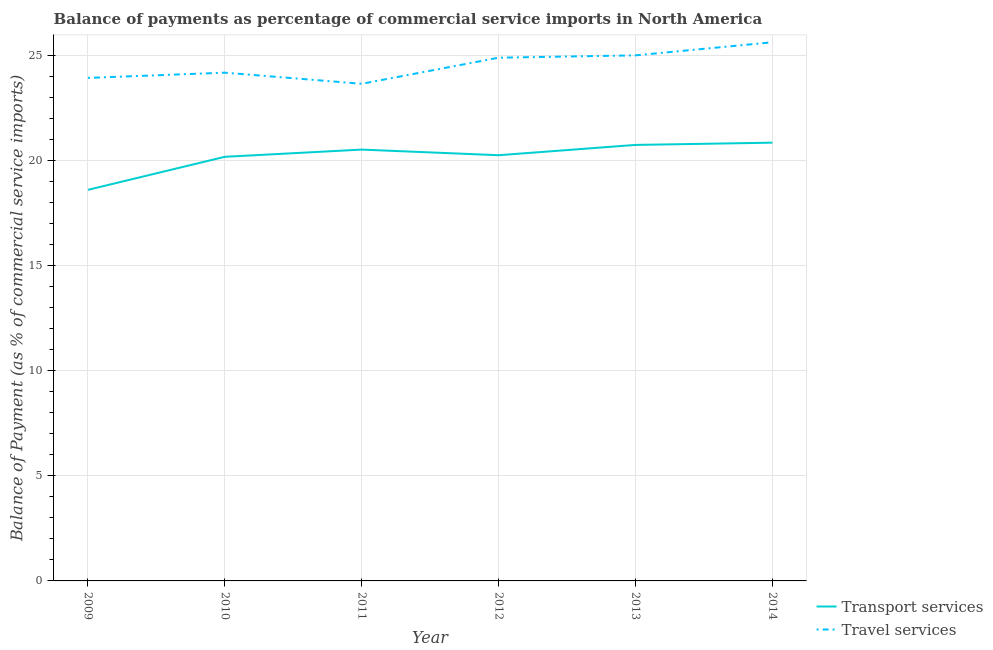Does the line corresponding to balance of payments of transport services intersect with the line corresponding to balance of payments of travel services?
Offer a very short reply. No. What is the balance of payments of travel services in 2013?
Make the answer very short. 24.99. Across all years, what is the maximum balance of payments of travel services?
Offer a very short reply. 25.61. Across all years, what is the minimum balance of payments of transport services?
Your answer should be compact. 18.59. In which year was the balance of payments of transport services minimum?
Give a very brief answer. 2009. What is the total balance of payments of travel services in the graph?
Your answer should be very brief. 147.2. What is the difference between the balance of payments of travel services in 2013 and that in 2014?
Your response must be concise. -0.62. What is the difference between the balance of payments of transport services in 2010 and the balance of payments of travel services in 2009?
Your response must be concise. -3.75. What is the average balance of payments of transport services per year?
Provide a short and direct response. 20.18. In the year 2014, what is the difference between the balance of payments of travel services and balance of payments of transport services?
Offer a very short reply. 4.77. What is the ratio of the balance of payments of travel services in 2011 to that in 2014?
Keep it short and to the point. 0.92. What is the difference between the highest and the second highest balance of payments of travel services?
Offer a very short reply. 0.62. What is the difference between the highest and the lowest balance of payments of transport services?
Offer a terse response. 2.24. In how many years, is the balance of payments of transport services greater than the average balance of payments of transport services taken over all years?
Keep it short and to the point. 4. Is the sum of the balance of payments of travel services in 2012 and 2014 greater than the maximum balance of payments of transport services across all years?
Offer a terse response. Yes. Does the balance of payments of travel services monotonically increase over the years?
Offer a terse response. No. Is the balance of payments of travel services strictly less than the balance of payments of transport services over the years?
Your answer should be very brief. No. Are the values on the major ticks of Y-axis written in scientific E-notation?
Keep it short and to the point. No. Does the graph contain any zero values?
Give a very brief answer. No. Does the graph contain grids?
Keep it short and to the point. Yes. Where does the legend appear in the graph?
Give a very brief answer. Bottom right. How many legend labels are there?
Offer a very short reply. 2. How are the legend labels stacked?
Make the answer very short. Vertical. What is the title of the graph?
Your answer should be compact. Balance of payments as percentage of commercial service imports in North America. What is the label or title of the X-axis?
Ensure brevity in your answer.  Year. What is the label or title of the Y-axis?
Your answer should be very brief. Balance of Payment (as % of commercial service imports). What is the Balance of Payment (as % of commercial service imports) in Transport services in 2009?
Provide a short and direct response. 18.59. What is the Balance of Payment (as % of commercial service imports) of Travel services in 2009?
Offer a terse response. 23.92. What is the Balance of Payment (as % of commercial service imports) of Transport services in 2010?
Ensure brevity in your answer.  20.17. What is the Balance of Payment (as % of commercial service imports) in Travel services in 2010?
Provide a succinct answer. 24.17. What is the Balance of Payment (as % of commercial service imports) of Transport services in 2011?
Offer a terse response. 20.51. What is the Balance of Payment (as % of commercial service imports) in Travel services in 2011?
Offer a terse response. 23.64. What is the Balance of Payment (as % of commercial service imports) of Transport services in 2012?
Your response must be concise. 20.24. What is the Balance of Payment (as % of commercial service imports) in Travel services in 2012?
Your answer should be compact. 24.88. What is the Balance of Payment (as % of commercial service imports) in Transport services in 2013?
Your answer should be very brief. 20.73. What is the Balance of Payment (as % of commercial service imports) in Travel services in 2013?
Your response must be concise. 24.99. What is the Balance of Payment (as % of commercial service imports) in Transport services in 2014?
Your answer should be compact. 20.84. What is the Balance of Payment (as % of commercial service imports) of Travel services in 2014?
Your answer should be compact. 25.61. Across all years, what is the maximum Balance of Payment (as % of commercial service imports) in Transport services?
Your answer should be very brief. 20.84. Across all years, what is the maximum Balance of Payment (as % of commercial service imports) of Travel services?
Your answer should be very brief. 25.61. Across all years, what is the minimum Balance of Payment (as % of commercial service imports) of Transport services?
Keep it short and to the point. 18.59. Across all years, what is the minimum Balance of Payment (as % of commercial service imports) in Travel services?
Your answer should be compact. 23.64. What is the total Balance of Payment (as % of commercial service imports) in Transport services in the graph?
Keep it short and to the point. 121.08. What is the total Balance of Payment (as % of commercial service imports) in Travel services in the graph?
Provide a short and direct response. 147.2. What is the difference between the Balance of Payment (as % of commercial service imports) of Transport services in 2009 and that in 2010?
Offer a terse response. -1.57. What is the difference between the Balance of Payment (as % of commercial service imports) of Travel services in 2009 and that in 2010?
Make the answer very short. -0.25. What is the difference between the Balance of Payment (as % of commercial service imports) in Transport services in 2009 and that in 2011?
Your answer should be compact. -1.91. What is the difference between the Balance of Payment (as % of commercial service imports) of Travel services in 2009 and that in 2011?
Provide a short and direct response. 0.28. What is the difference between the Balance of Payment (as % of commercial service imports) of Transport services in 2009 and that in 2012?
Offer a very short reply. -1.65. What is the difference between the Balance of Payment (as % of commercial service imports) in Travel services in 2009 and that in 2012?
Provide a short and direct response. -0.96. What is the difference between the Balance of Payment (as % of commercial service imports) of Transport services in 2009 and that in 2013?
Ensure brevity in your answer.  -2.14. What is the difference between the Balance of Payment (as % of commercial service imports) of Travel services in 2009 and that in 2013?
Give a very brief answer. -1.07. What is the difference between the Balance of Payment (as % of commercial service imports) in Transport services in 2009 and that in 2014?
Provide a short and direct response. -2.24. What is the difference between the Balance of Payment (as % of commercial service imports) in Travel services in 2009 and that in 2014?
Ensure brevity in your answer.  -1.7. What is the difference between the Balance of Payment (as % of commercial service imports) in Transport services in 2010 and that in 2011?
Make the answer very short. -0.34. What is the difference between the Balance of Payment (as % of commercial service imports) of Travel services in 2010 and that in 2011?
Your answer should be very brief. 0.53. What is the difference between the Balance of Payment (as % of commercial service imports) of Transport services in 2010 and that in 2012?
Offer a terse response. -0.08. What is the difference between the Balance of Payment (as % of commercial service imports) of Travel services in 2010 and that in 2012?
Give a very brief answer. -0.71. What is the difference between the Balance of Payment (as % of commercial service imports) of Transport services in 2010 and that in 2013?
Provide a short and direct response. -0.57. What is the difference between the Balance of Payment (as % of commercial service imports) of Travel services in 2010 and that in 2013?
Provide a short and direct response. -0.82. What is the difference between the Balance of Payment (as % of commercial service imports) in Transport services in 2010 and that in 2014?
Make the answer very short. -0.67. What is the difference between the Balance of Payment (as % of commercial service imports) of Travel services in 2010 and that in 2014?
Make the answer very short. -1.45. What is the difference between the Balance of Payment (as % of commercial service imports) of Transport services in 2011 and that in 2012?
Your response must be concise. 0.27. What is the difference between the Balance of Payment (as % of commercial service imports) of Travel services in 2011 and that in 2012?
Make the answer very short. -1.24. What is the difference between the Balance of Payment (as % of commercial service imports) in Transport services in 2011 and that in 2013?
Ensure brevity in your answer.  -0.22. What is the difference between the Balance of Payment (as % of commercial service imports) of Travel services in 2011 and that in 2013?
Provide a short and direct response. -1.35. What is the difference between the Balance of Payment (as % of commercial service imports) of Transport services in 2011 and that in 2014?
Keep it short and to the point. -0.33. What is the difference between the Balance of Payment (as % of commercial service imports) of Travel services in 2011 and that in 2014?
Your response must be concise. -1.98. What is the difference between the Balance of Payment (as % of commercial service imports) in Transport services in 2012 and that in 2013?
Offer a very short reply. -0.49. What is the difference between the Balance of Payment (as % of commercial service imports) of Travel services in 2012 and that in 2013?
Give a very brief answer. -0.11. What is the difference between the Balance of Payment (as % of commercial service imports) in Transport services in 2012 and that in 2014?
Provide a succinct answer. -0.6. What is the difference between the Balance of Payment (as % of commercial service imports) in Travel services in 2012 and that in 2014?
Keep it short and to the point. -0.73. What is the difference between the Balance of Payment (as % of commercial service imports) in Transport services in 2013 and that in 2014?
Offer a very short reply. -0.11. What is the difference between the Balance of Payment (as % of commercial service imports) in Travel services in 2013 and that in 2014?
Your response must be concise. -0.62. What is the difference between the Balance of Payment (as % of commercial service imports) in Transport services in 2009 and the Balance of Payment (as % of commercial service imports) in Travel services in 2010?
Ensure brevity in your answer.  -5.57. What is the difference between the Balance of Payment (as % of commercial service imports) in Transport services in 2009 and the Balance of Payment (as % of commercial service imports) in Travel services in 2011?
Your answer should be compact. -5.04. What is the difference between the Balance of Payment (as % of commercial service imports) of Transport services in 2009 and the Balance of Payment (as % of commercial service imports) of Travel services in 2012?
Provide a succinct answer. -6.28. What is the difference between the Balance of Payment (as % of commercial service imports) of Transport services in 2009 and the Balance of Payment (as % of commercial service imports) of Travel services in 2013?
Your answer should be very brief. -6.39. What is the difference between the Balance of Payment (as % of commercial service imports) in Transport services in 2009 and the Balance of Payment (as % of commercial service imports) in Travel services in 2014?
Your answer should be very brief. -7.02. What is the difference between the Balance of Payment (as % of commercial service imports) in Transport services in 2010 and the Balance of Payment (as % of commercial service imports) in Travel services in 2011?
Your response must be concise. -3.47. What is the difference between the Balance of Payment (as % of commercial service imports) in Transport services in 2010 and the Balance of Payment (as % of commercial service imports) in Travel services in 2012?
Offer a terse response. -4.71. What is the difference between the Balance of Payment (as % of commercial service imports) in Transport services in 2010 and the Balance of Payment (as % of commercial service imports) in Travel services in 2013?
Keep it short and to the point. -4.82. What is the difference between the Balance of Payment (as % of commercial service imports) of Transport services in 2010 and the Balance of Payment (as % of commercial service imports) of Travel services in 2014?
Provide a short and direct response. -5.45. What is the difference between the Balance of Payment (as % of commercial service imports) of Transport services in 2011 and the Balance of Payment (as % of commercial service imports) of Travel services in 2012?
Your answer should be very brief. -4.37. What is the difference between the Balance of Payment (as % of commercial service imports) in Transport services in 2011 and the Balance of Payment (as % of commercial service imports) in Travel services in 2013?
Your answer should be compact. -4.48. What is the difference between the Balance of Payment (as % of commercial service imports) in Transport services in 2011 and the Balance of Payment (as % of commercial service imports) in Travel services in 2014?
Offer a very short reply. -5.1. What is the difference between the Balance of Payment (as % of commercial service imports) in Transport services in 2012 and the Balance of Payment (as % of commercial service imports) in Travel services in 2013?
Keep it short and to the point. -4.75. What is the difference between the Balance of Payment (as % of commercial service imports) of Transport services in 2012 and the Balance of Payment (as % of commercial service imports) of Travel services in 2014?
Offer a very short reply. -5.37. What is the difference between the Balance of Payment (as % of commercial service imports) of Transport services in 2013 and the Balance of Payment (as % of commercial service imports) of Travel services in 2014?
Make the answer very short. -4.88. What is the average Balance of Payment (as % of commercial service imports) in Transport services per year?
Offer a very short reply. 20.18. What is the average Balance of Payment (as % of commercial service imports) in Travel services per year?
Give a very brief answer. 24.53. In the year 2009, what is the difference between the Balance of Payment (as % of commercial service imports) of Transport services and Balance of Payment (as % of commercial service imports) of Travel services?
Your answer should be compact. -5.32. In the year 2010, what is the difference between the Balance of Payment (as % of commercial service imports) in Transport services and Balance of Payment (as % of commercial service imports) in Travel services?
Your answer should be very brief. -4. In the year 2011, what is the difference between the Balance of Payment (as % of commercial service imports) of Transport services and Balance of Payment (as % of commercial service imports) of Travel services?
Your answer should be very brief. -3.13. In the year 2012, what is the difference between the Balance of Payment (as % of commercial service imports) in Transport services and Balance of Payment (as % of commercial service imports) in Travel services?
Offer a terse response. -4.64. In the year 2013, what is the difference between the Balance of Payment (as % of commercial service imports) in Transport services and Balance of Payment (as % of commercial service imports) in Travel services?
Your response must be concise. -4.26. In the year 2014, what is the difference between the Balance of Payment (as % of commercial service imports) in Transport services and Balance of Payment (as % of commercial service imports) in Travel services?
Provide a short and direct response. -4.77. What is the ratio of the Balance of Payment (as % of commercial service imports) of Transport services in 2009 to that in 2010?
Your answer should be compact. 0.92. What is the ratio of the Balance of Payment (as % of commercial service imports) in Transport services in 2009 to that in 2011?
Keep it short and to the point. 0.91. What is the ratio of the Balance of Payment (as % of commercial service imports) in Travel services in 2009 to that in 2011?
Offer a very short reply. 1.01. What is the ratio of the Balance of Payment (as % of commercial service imports) in Transport services in 2009 to that in 2012?
Offer a very short reply. 0.92. What is the ratio of the Balance of Payment (as % of commercial service imports) of Travel services in 2009 to that in 2012?
Provide a short and direct response. 0.96. What is the ratio of the Balance of Payment (as % of commercial service imports) in Transport services in 2009 to that in 2013?
Offer a very short reply. 0.9. What is the ratio of the Balance of Payment (as % of commercial service imports) of Travel services in 2009 to that in 2013?
Give a very brief answer. 0.96. What is the ratio of the Balance of Payment (as % of commercial service imports) of Transport services in 2009 to that in 2014?
Make the answer very short. 0.89. What is the ratio of the Balance of Payment (as % of commercial service imports) of Travel services in 2009 to that in 2014?
Offer a terse response. 0.93. What is the ratio of the Balance of Payment (as % of commercial service imports) in Transport services in 2010 to that in 2011?
Your answer should be compact. 0.98. What is the ratio of the Balance of Payment (as % of commercial service imports) in Travel services in 2010 to that in 2011?
Your answer should be very brief. 1.02. What is the ratio of the Balance of Payment (as % of commercial service imports) in Travel services in 2010 to that in 2012?
Offer a very short reply. 0.97. What is the ratio of the Balance of Payment (as % of commercial service imports) in Transport services in 2010 to that in 2013?
Offer a very short reply. 0.97. What is the ratio of the Balance of Payment (as % of commercial service imports) of Travel services in 2010 to that in 2013?
Ensure brevity in your answer.  0.97. What is the ratio of the Balance of Payment (as % of commercial service imports) in Transport services in 2010 to that in 2014?
Your answer should be compact. 0.97. What is the ratio of the Balance of Payment (as % of commercial service imports) in Travel services in 2010 to that in 2014?
Your response must be concise. 0.94. What is the ratio of the Balance of Payment (as % of commercial service imports) in Transport services in 2011 to that in 2012?
Offer a terse response. 1.01. What is the ratio of the Balance of Payment (as % of commercial service imports) of Travel services in 2011 to that in 2012?
Ensure brevity in your answer.  0.95. What is the ratio of the Balance of Payment (as % of commercial service imports) of Transport services in 2011 to that in 2013?
Provide a succinct answer. 0.99. What is the ratio of the Balance of Payment (as % of commercial service imports) of Travel services in 2011 to that in 2013?
Your answer should be very brief. 0.95. What is the ratio of the Balance of Payment (as % of commercial service imports) of Transport services in 2011 to that in 2014?
Offer a very short reply. 0.98. What is the ratio of the Balance of Payment (as % of commercial service imports) in Travel services in 2011 to that in 2014?
Your response must be concise. 0.92. What is the ratio of the Balance of Payment (as % of commercial service imports) in Transport services in 2012 to that in 2013?
Keep it short and to the point. 0.98. What is the ratio of the Balance of Payment (as % of commercial service imports) of Transport services in 2012 to that in 2014?
Your answer should be compact. 0.97. What is the ratio of the Balance of Payment (as % of commercial service imports) of Travel services in 2012 to that in 2014?
Your answer should be compact. 0.97. What is the ratio of the Balance of Payment (as % of commercial service imports) in Transport services in 2013 to that in 2014?
Make the answer very short. 0.99. What is the ratio of the Balance of Payment (as % of commercial service imports) of Travel services in 2013 to that in 2014?
Your response must be concise. 0.98. What is the difference between the highest and the second highest Balance of Payment (as % of commercial service imports) in Transport services?
Make the answer very short. 0.11. What is the difference between the highest and the second highest Balance of Payment (as % of commercial service imports) in Travel services?
Provide a succinct answer. 0.62. What is the difference between the highest and the lowest Balance of Payment (as % of commercial service imports) of Transport services?
Give a very brief answer. 2.24. What is the difference between the highest and the lowest Balance of Payment (as % of commercial service imports) in Travel services?
Offer a very short reply. 1.98. 